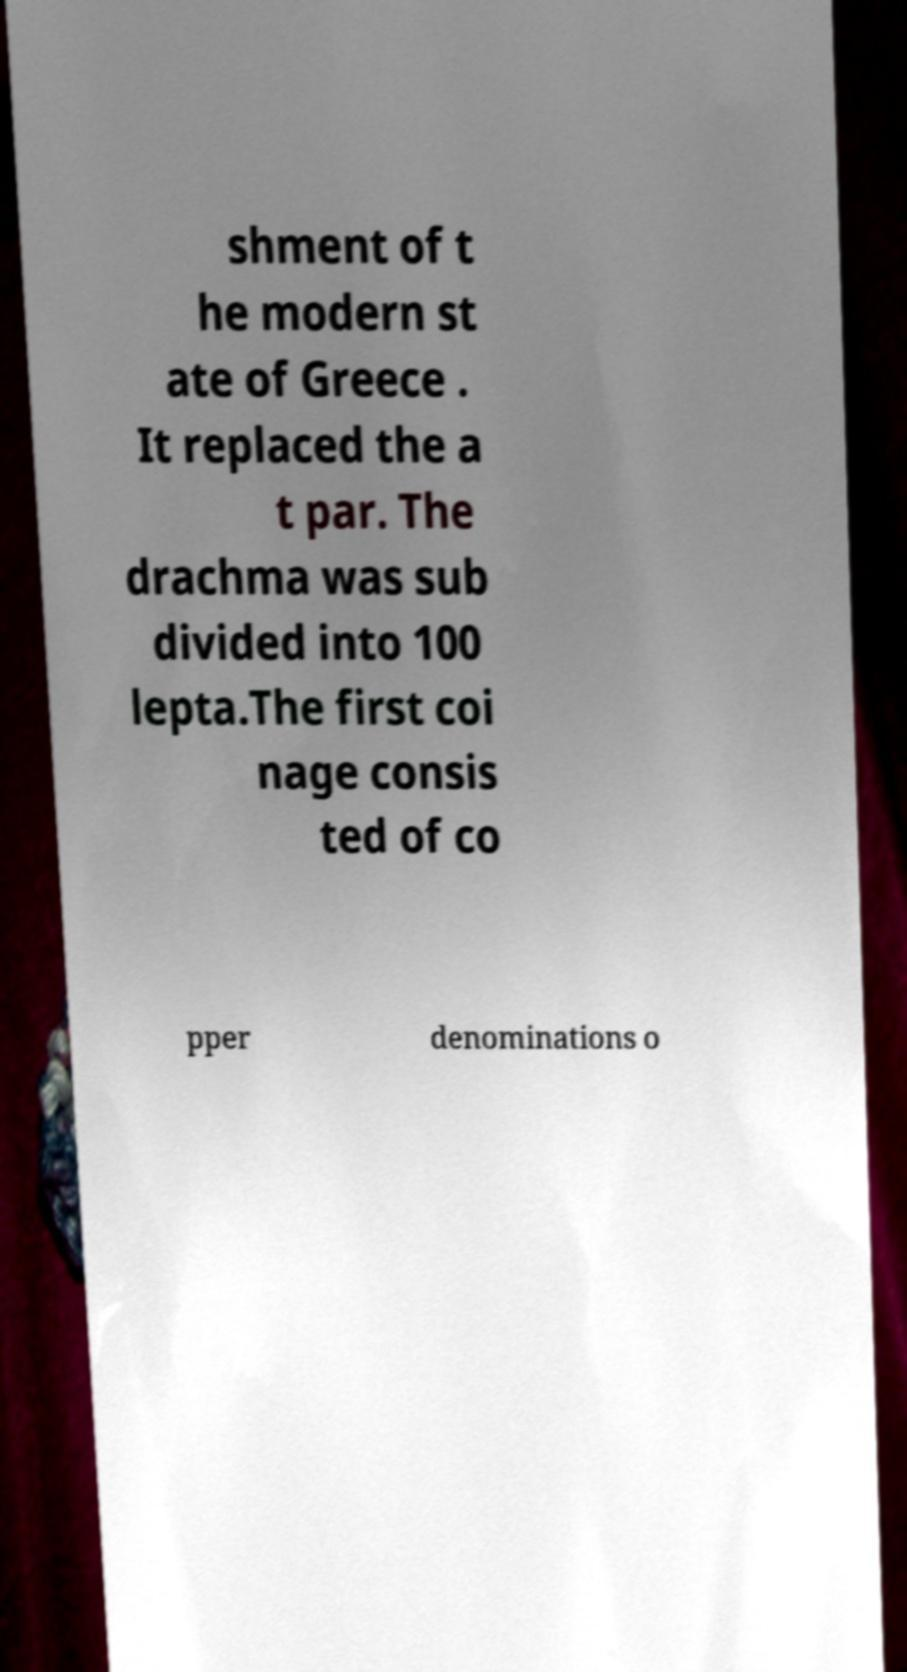Please identify and transcribe the text found in this image. shment of t he modern st ate of Greece . It replaced the a t par. The drachma was sub divided into 100 lepta.The first coi nage consis ted of co pper denominations o 